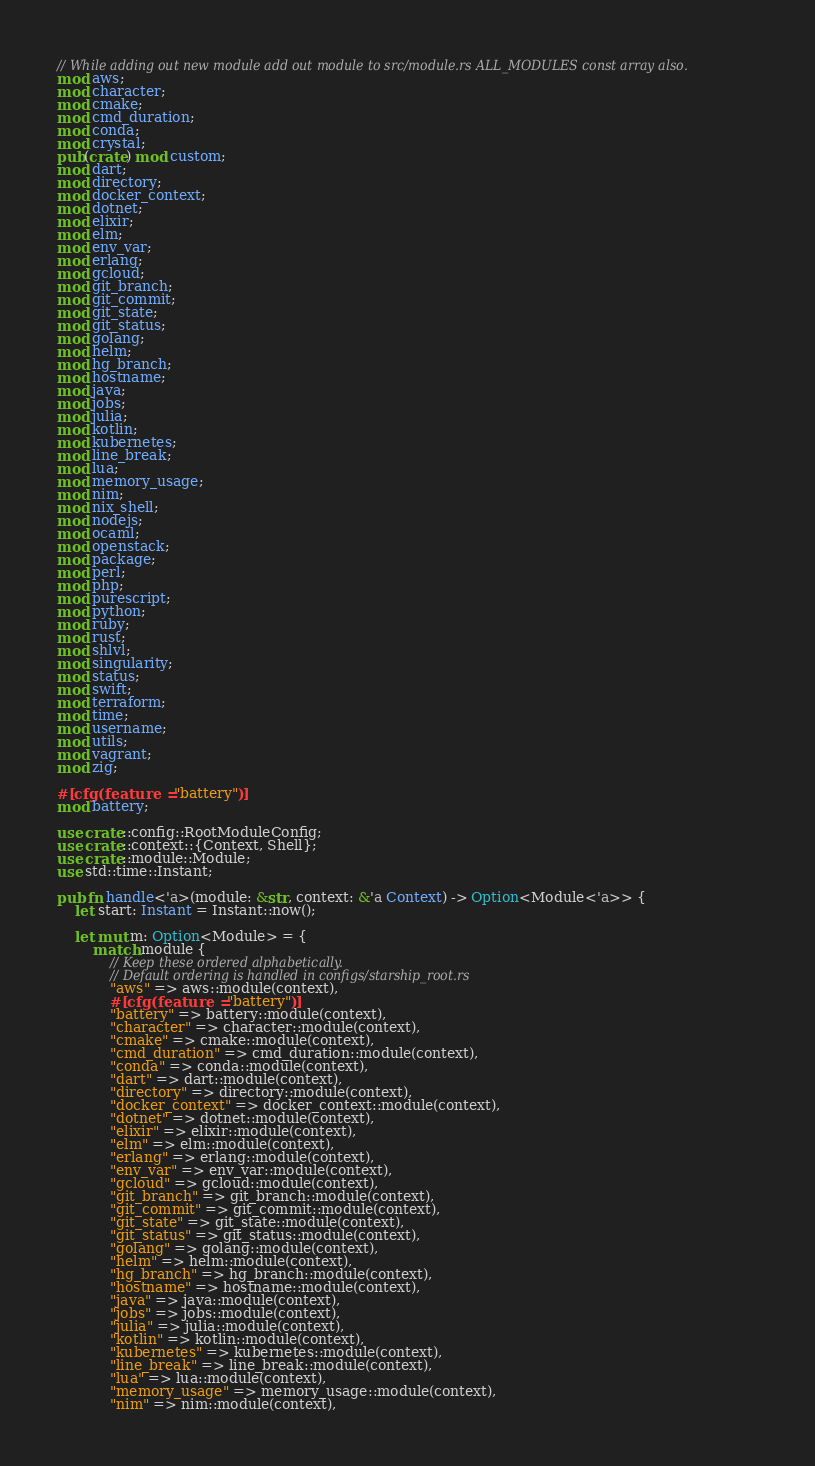<code> <loc_0><loc_0><loc_500><loc_500><_Rust_>// While adding out new module add out module to src/module.rs ALL_MODULES const array also.
mod aws;
mod character;
mod cmake;
mod cmd_duration;
mod conda;
mod crystal;
pub(crate) mod custom;
mod dart;
mod directory;
mod docker_context;
mod dotnet;
mod elixir;
mod elm;
mod env_var;
mod erlang;
mod gcloud;
mod git_branch;
mod git_commit;
mod git_state;
mod git_status;
mod golang;
mod helm;
mod hg_branch;
mod hostname;
mod java;
mod jobs;
mod julia;
mod kotlin;
mod kubernetes;
mod line_break;
mod lua;
mod memory_usage;
mod nim;
mod nix_shell;
mod nodejs;
mod ocaml;
mod openstack;
mod package;
mod perl;
mod php;
mod purescript;
mod python;
mod ruby;
mod rust;
mod shlvl;
mod singularity;
mod status;
mod swift;
mod terraform;
mod time;
mod username;
mod utils;
mod vagrant;
mod zig;

#[cfg(feature = "battery")]
mod battery;

use crate::config::RootModuleConfig;
use crate::context::{Context, Shell};
use crate::module::Module;
use std::time::Instant;

pub fn handle<'a>(module: &str, context: &'a Context) -> Option<Module<'a>> {
    let start: Instant = Instant::now();

    let mut m: Option<Module> = {
        match module {
            // Keep these ordered alphabetically.
            // Default ordering is handled in configs/starship_root.rs
            "aws" => aws::module(context),
            #[cfg(feature = "battery")]
            "battery" => battery::module(context),
            "character" => character::module(context),
            "cmake" => cmake::module(context),
            "cmd_duration" => cmd_duration::module(context),
            "conda" => conda::module(context),
            "dart" => dart::module(context),
            "directory" => directory::module(context),
            "docker_context" => docker_context::module(context),
            "dotnet" => dotnet::module(context),
            "elixir" => elixir::module(context),
            "elm" => elm::module(context),
            "erlang" => erlang::module(context),
            "env_var" => env_var::module(context),
            "gcloud" => gcloud::module(context),
            "git_branch" => git_branch::module(context),
            "git_commit" => git_commit::module(context),
            "git_state" => git_state::module(context),
            "git_status" => git_status::module(context),
            "golang" => golang::module(context),
            "helm" => helm::module(context),
            "hg_branch" => hg_branch::module(context),
            "hostname" => hostname::module(context),
            "java" => java::module(context),
            "jobs" => jobs::module(context),
            "julia" => julia::module(context),
            "kotlin" => kotlin::module(context),
            "kubernetes" => kubernetes::module(context),
            "line_break" => line_break::module(context),
            "lua" => lua::module(context),
            "memory_usage" => memory_usage::module(context),
            "nim" => nim::module(context),</code> 